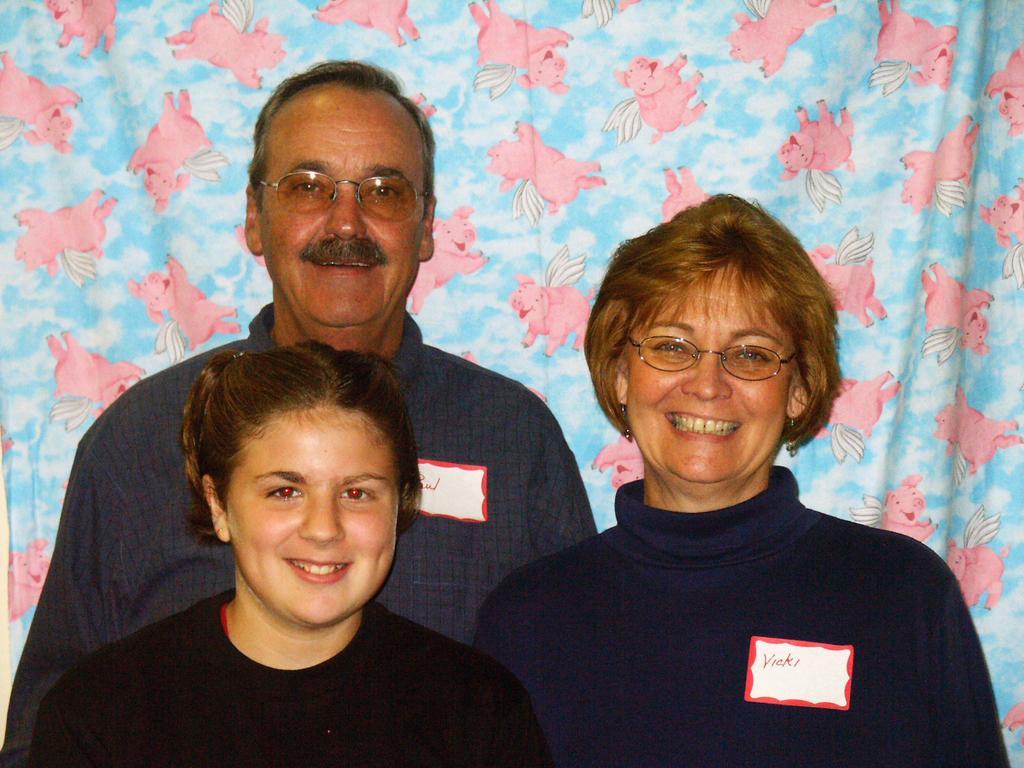Please provide a concise description of this image. In this picture there are three people standing and smiling. At the back there is a curtain and there are pictures of pigs and there is a picture of sky on the curtain. 